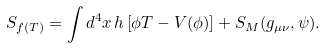<formula> <loc_0><loc_0><loc_500><loc_500>S _ { f ( T ) } = \int d ^ { 4 } x \, h \left [ \phi T - V ( \phi ) \right ] + S _ { M } ( g _ { \mu \nu } , \psi ) .</formula> 